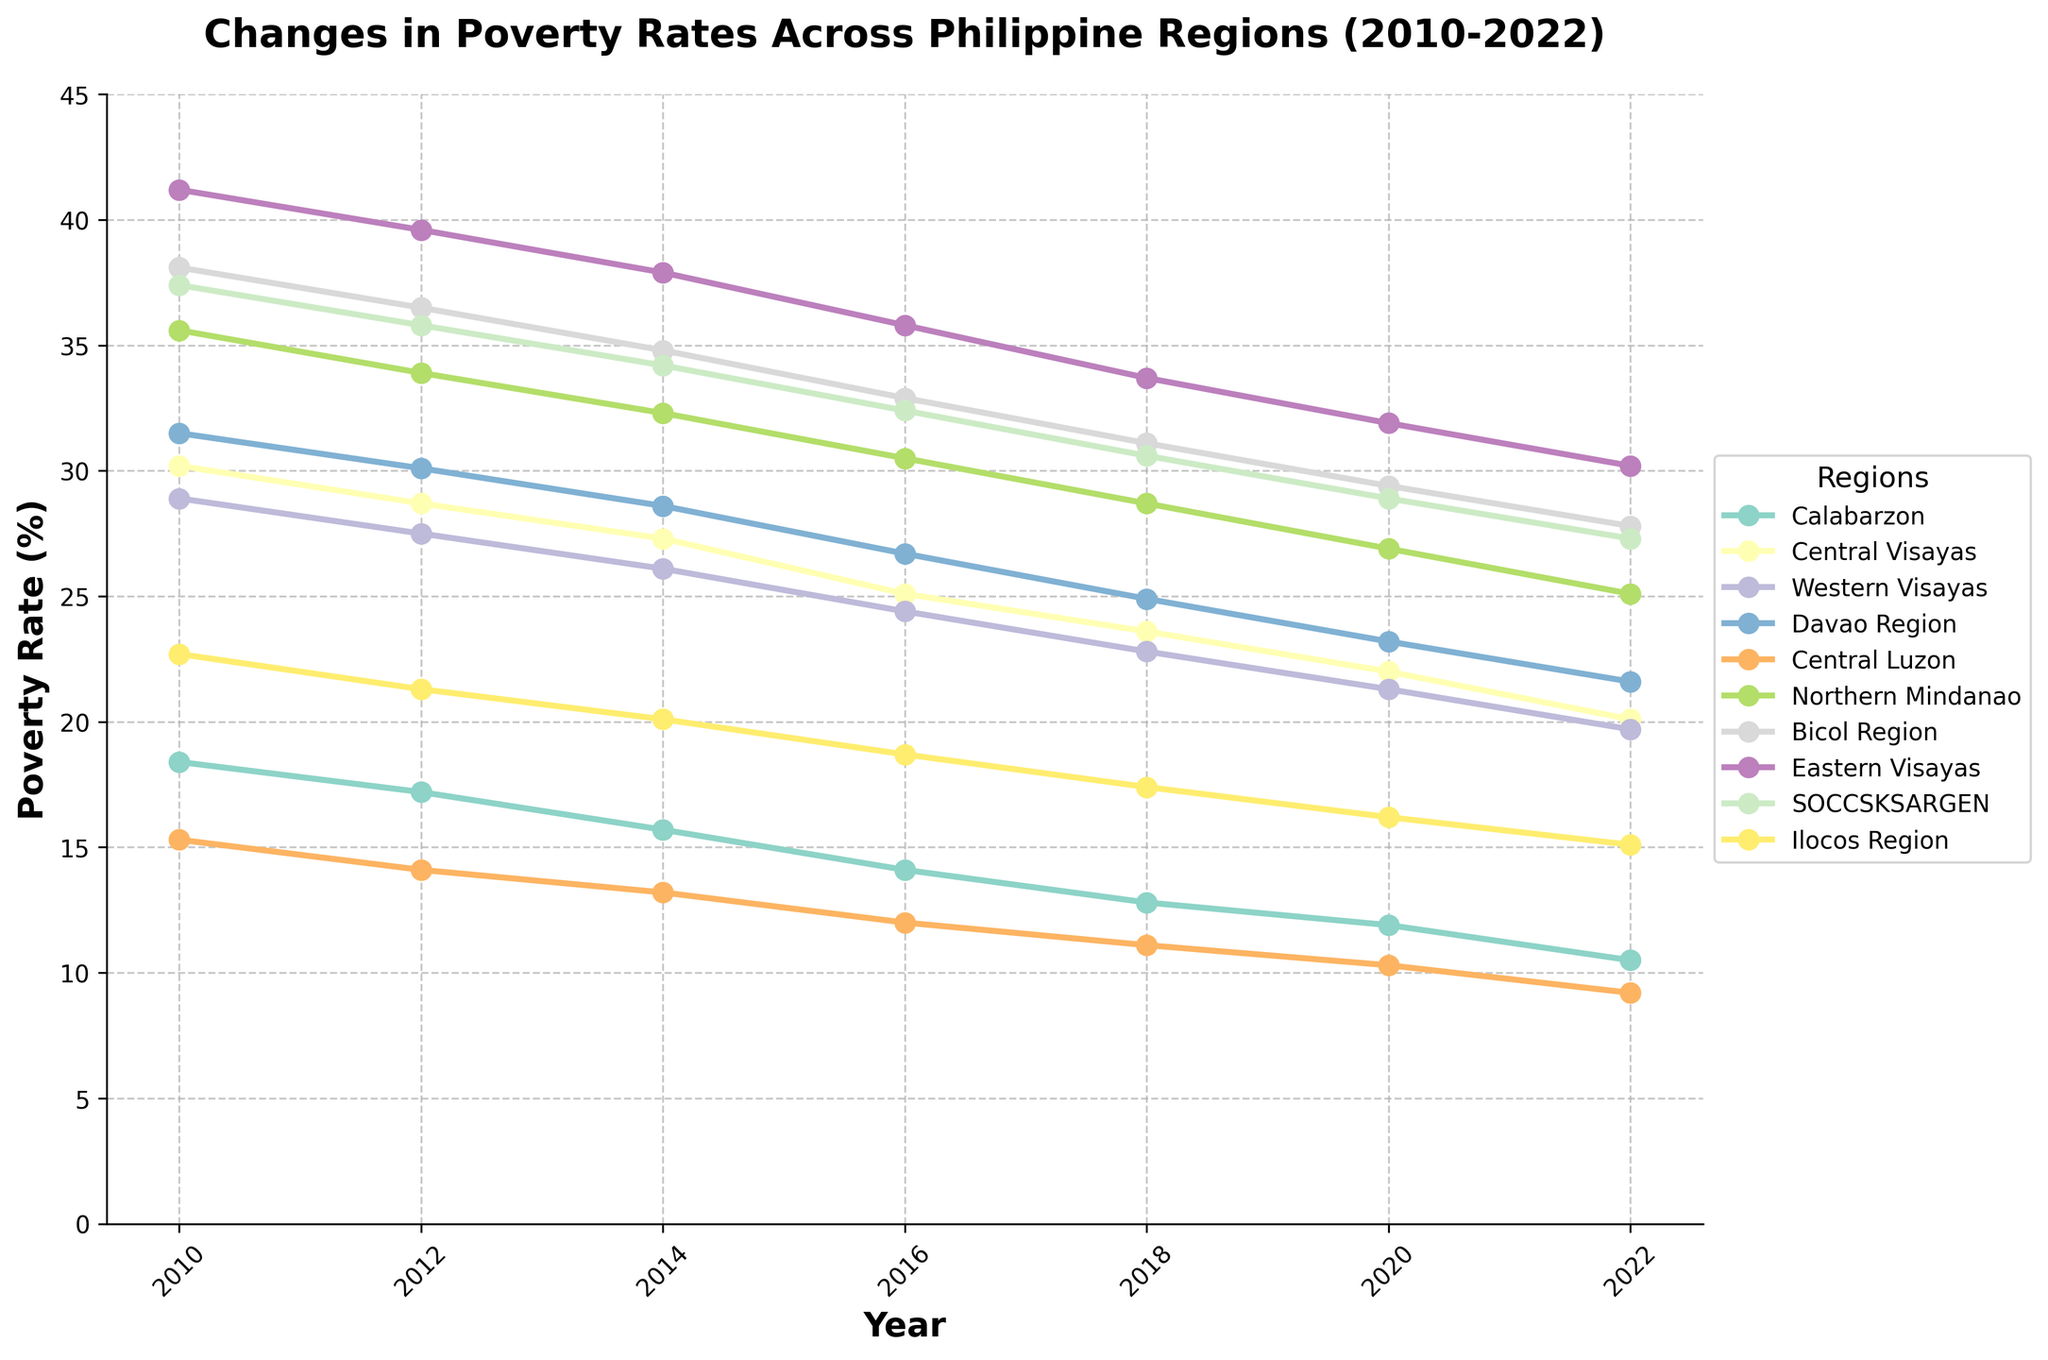Which region had the highest poverty rate in 2010? To find the region with the highest poverty rate in 2010, look at the values for each region in 2010 and identify the largest number. The highest value is 41.2, which corresponds to Eastern Visayas.
Answer: Eastern Visayas Which region showed the greatest reduction in poverty rate from 2010 to 2022? Calculate the difference in poverty rates from 2010 to 2022 for each region and identify the largest reduction. Eastern Visayas had a 11 percentage point decrease (41.2 - 30.2 = 11).
Answer: Eastern Visayas What was the average poverty rate across all regions in 2022? Sum the poverty rates for all regions in 2022 and divide by the number of regions. The sum is 10.5 + 20.1 + 19.7 + 21.6 + 9.2 + 25.1 + 27.8 + 30.2 + 27.3 + 15.1 = 206.5, and the number of regions is 10, so the average is 206.5 / 10 = 20.65.
Answer: 20.65 Between which two consecutive years did Central Luzon see the largest drop in poverty rate? Calculate the changes in poverty rate for Central Luzon between consecutive years and identify the largest drop. The changes are: 2010-2012: 15.3 - 14.1 = 1.2, 2012-2014: 14.1 - 13.2 = 0.9, 2014-2016: 13.2 - 12.0 = 1.2, 2016-2018: 12.0 - 11.1 = 0.9, 2018-2020: 11.1 - 10.3 = 0.8, 2020-2022: 10.3 - 9.2 = 1.1. The largest drop is from 2010-2012 and 2014-2016, both 1.2 percentage points.
Answer: 2010-2012 and 2014-2016 Which region had a lower poverty rate in 2022 than Calabarzon's poverty rate in 2016? Compare each region's poverty rate in 2022 to Calabarzon's poverty rate in 2016 (14.1). The regions with lower rates in 2022 are Calabarzon (10.5) and Central Luzon (9.2).
Answer: Calabarzon, Central Luzon Which two regions were closest in their poverty rates in 2022, and what were those rates? Look at the 2022 rates and find the smallest difference between two regions. Western Visayas (19.7) and Central Visayas (20.1) have the smallest difference (0.4).
Answer: Western Visayas (19.7), Central Visayas (20.1) Did any region have an increasing poverty rate from 2018 to 2022? Examine the poverty rates for each region from 2018 to 2022 to see if any values increased. All regions show a decrease in poverty rates from 2018 to 2022.
Answer: No Which region had the second-highest poverty rate in 2020? Rank the regions by their poverty rates in 2020 and identify the second-highest. Bicol Region had the second-highest rate in 2020 at 29.4.
Answer: Bicol Region In 2012, which region had a poverty rate closest to the national average across the listed regions? Calculate the national average poverty rate across the 10 regions in 2012. The sum of rates for 2012 is 254.7, and the average is 254.7 / 10 = 25.47. Central Visayas with 28.7 is closest to this average.
Answer: Central Visayas 